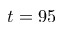Convert formula to latex. <formula><loc_0><loc_0><loc_500><loc_500>t = 9 5</formula> 